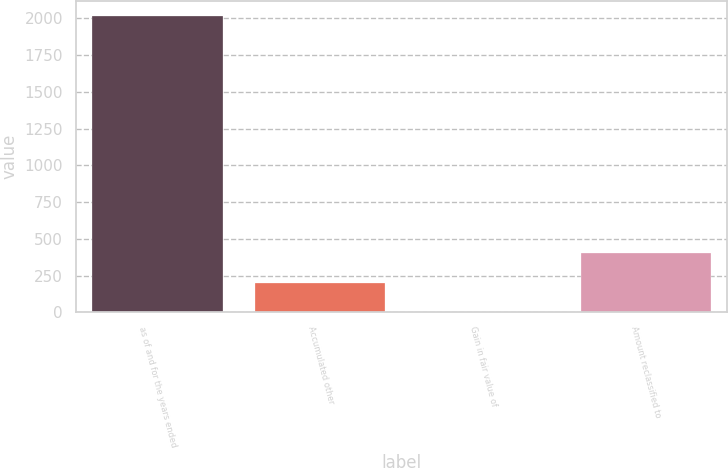<chart> <loc_0><loc_0><loc_500><loc_500><bar_chart><fcel>as of and for the years ended<fcel>Accumulated other<fcel>Gain in fair value of<fcel>Amount reclassified to<nl><fcel>2016<fcel>202.5<fcel>1<fcel>404<nl></chart> 